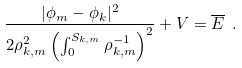Convert formula to latex. <formula><loc_0><loc_0><loc_500><loc_500>\frac { | \phi _ { m } - \phi _ { k } | ^ { 2 } } { 2 \rho _ { k , m } ^ { 2 } \left ( \int _ { 0 } ^ { S _ { k , m } } \rho _ { k , m } ^ { - 1 } \right ) ^ { 2 } } + V = \overline { E } \ .</formula> 